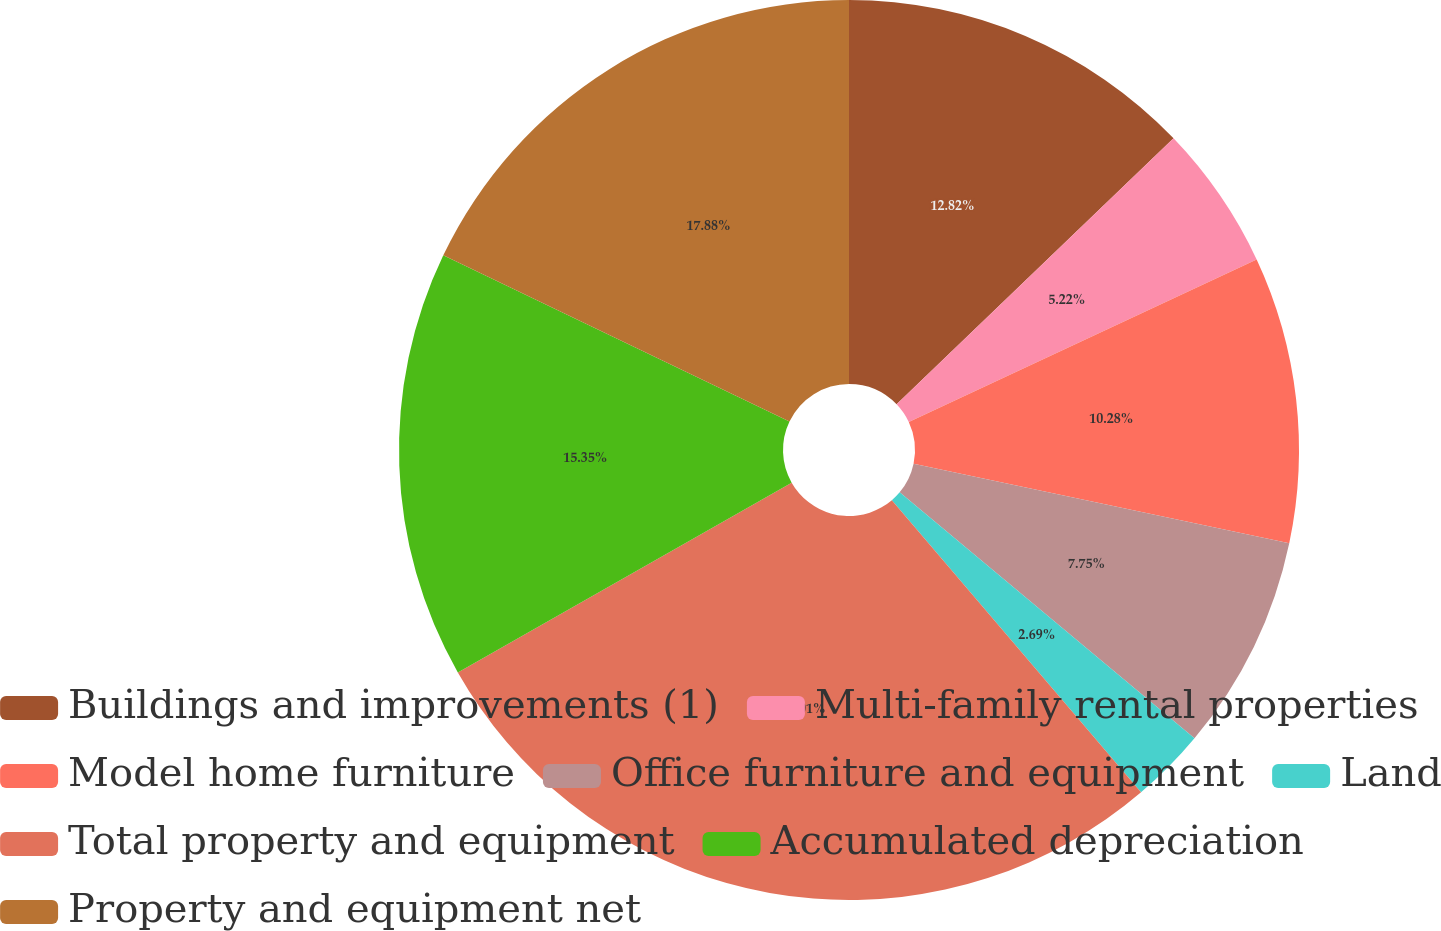Convert chart. <chart><loc_0><loc_0><loc_500><loc_500><pie_chart><fcel>Buildings and improvements (1)<fcel>Multi-family rental properties<fcel>Model home furniture<fcel>Office furniture and equipment<fcel>Land<fcel>Total property and equipment<fcel>Accumulated depreciation<fcel>Property and equipment net<nl><fcel>12.82%<fcel>5.22%<fcel>10.28%<fcel>7.75%<fcel>2.69%<fcel>28.01%<fcel>15.35%<fcel>17.88%<nl></chart> 